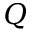<formula> <loc_0><loc_0><loc_500><loc_500>Q</formula> 